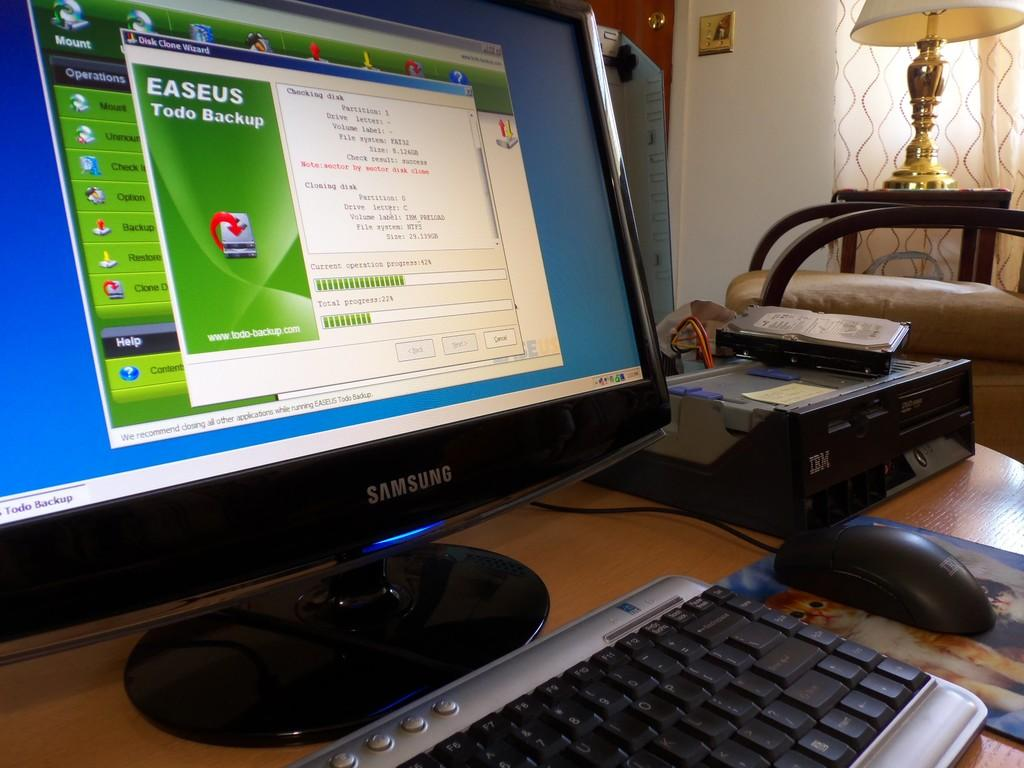<image>
Provide a brief description of the given image. a samsung monitor open to the easeus todo backup app 